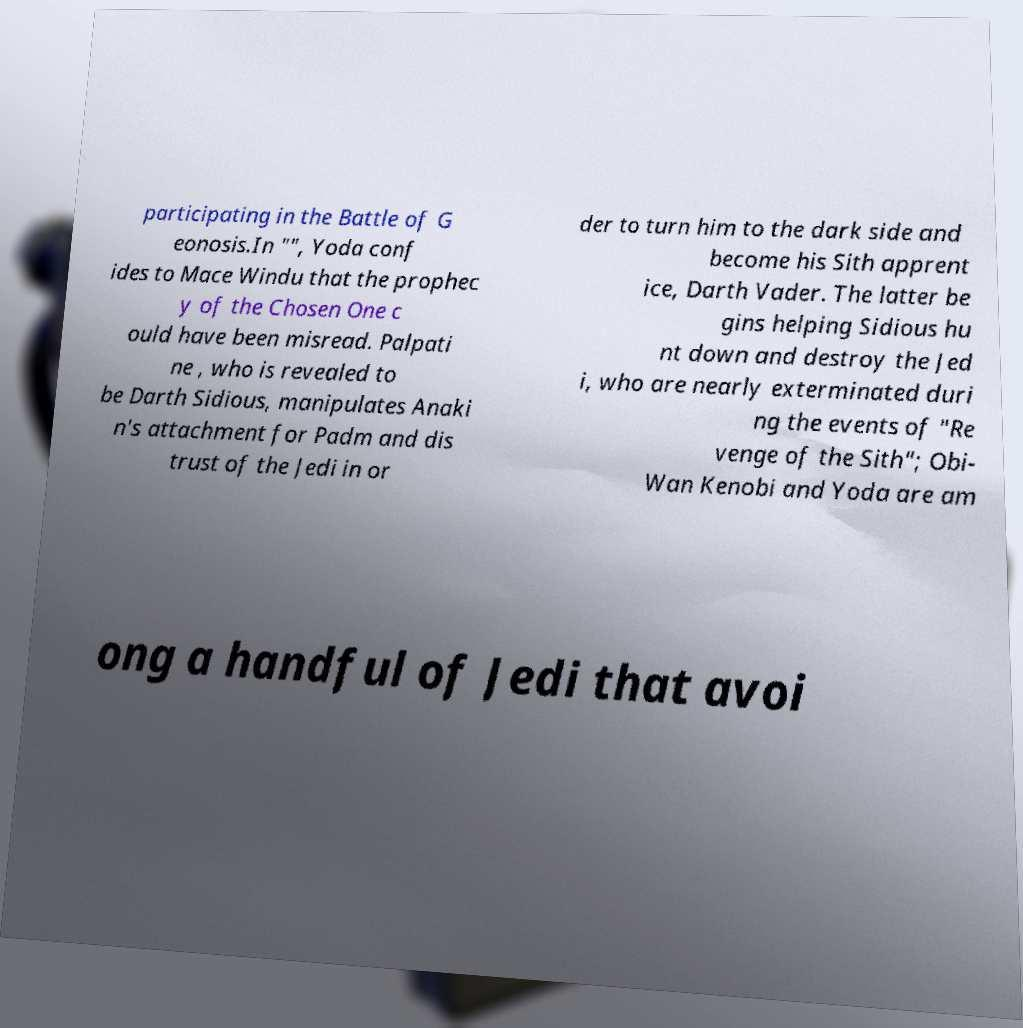Can you read and provide the text displayed in the image?This photo seems to have some interesting text. Can you extract and type it out for me? participating in the Battle of G eonosis.In "", Yoda conf ides to Mace Windu that the prophec y of the Chosen One c ould have been misread. Palpati ne , who is revealed to be Darth Sidious, manipulates Anaki n's attachment for Padm and dis trust of the Jedi in or der to turn him to the dark side and become his Sith apprent ice, Darth Vader. The latter be gins helping Sidious hu nt down and destroy the Jed i, who are nearly exterminated duri ng the events of "Re venge of the Sith"; Obi- Wan Kenobi and Yoda are am ong a handful of Jedi that avoi 